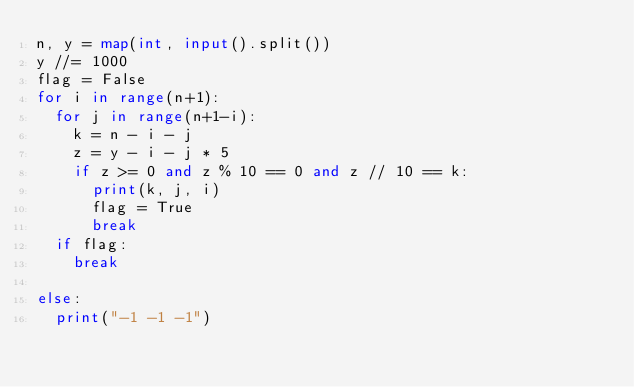Convert code to text. <code><loc_0><loc_0><loc_500><loc_500><_Python_>n, y = map(int, input().split())
y //= 1000
flag = False
for i in range(n+1):
  for j in range(n+1-i):
    k = n - i - j
    z = y - i - j * 5
    if z >= 0 and z % 10 == 0 and z // 10 == k:
      print(k, j, i)
      flag = True
      break
  if flag:
    break
  
else:
  print("-1 -1 -1")</code> 